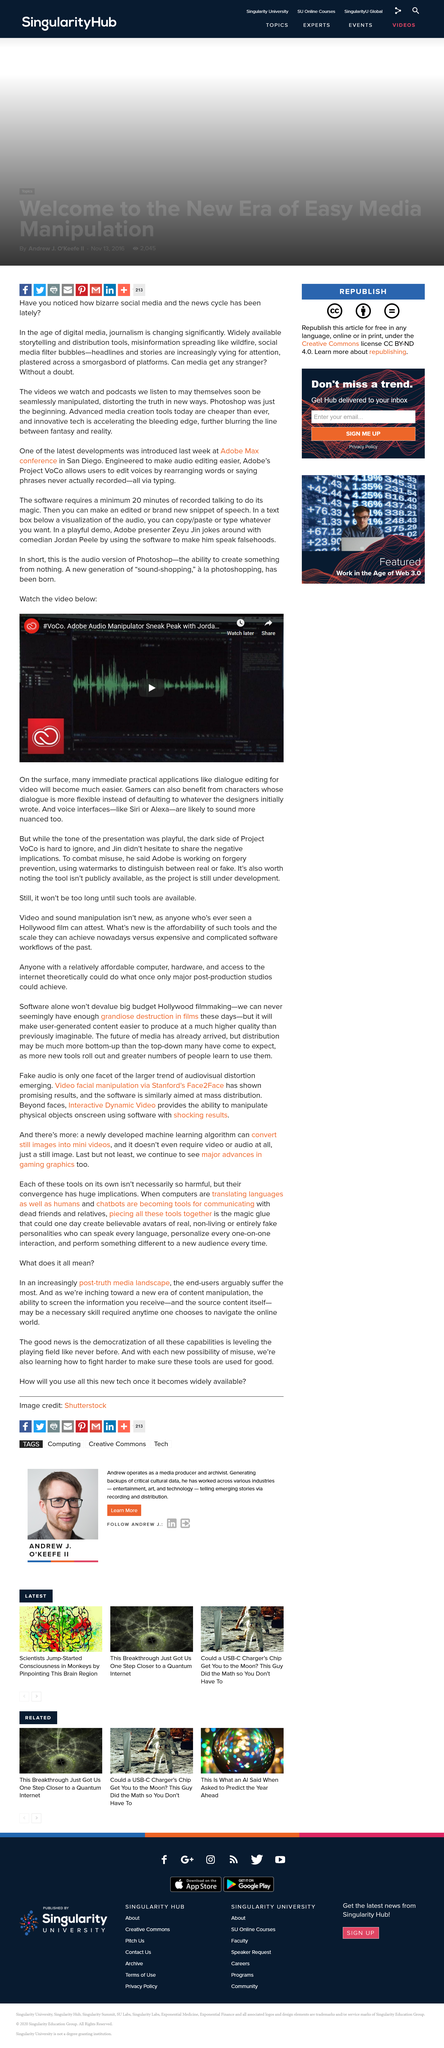Highlight a few significant elements in this photo. Dialogue editing for video will be easier than before. Adobe is taking steps to prevent misuse of its Project VoCo technology by implementing forgery prevention measures. Gamers can benefit from flexible dialogue as it provides a better experience than what the designers initially wrote. 